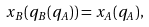Convert formula to latex. <formula><loc_0><loc_0><loc_500><loc_500>x _ { B } ( q _ { B } ( q _ { A } ) ) = x _ { A } ( q _ { A } ) ,</formula> 